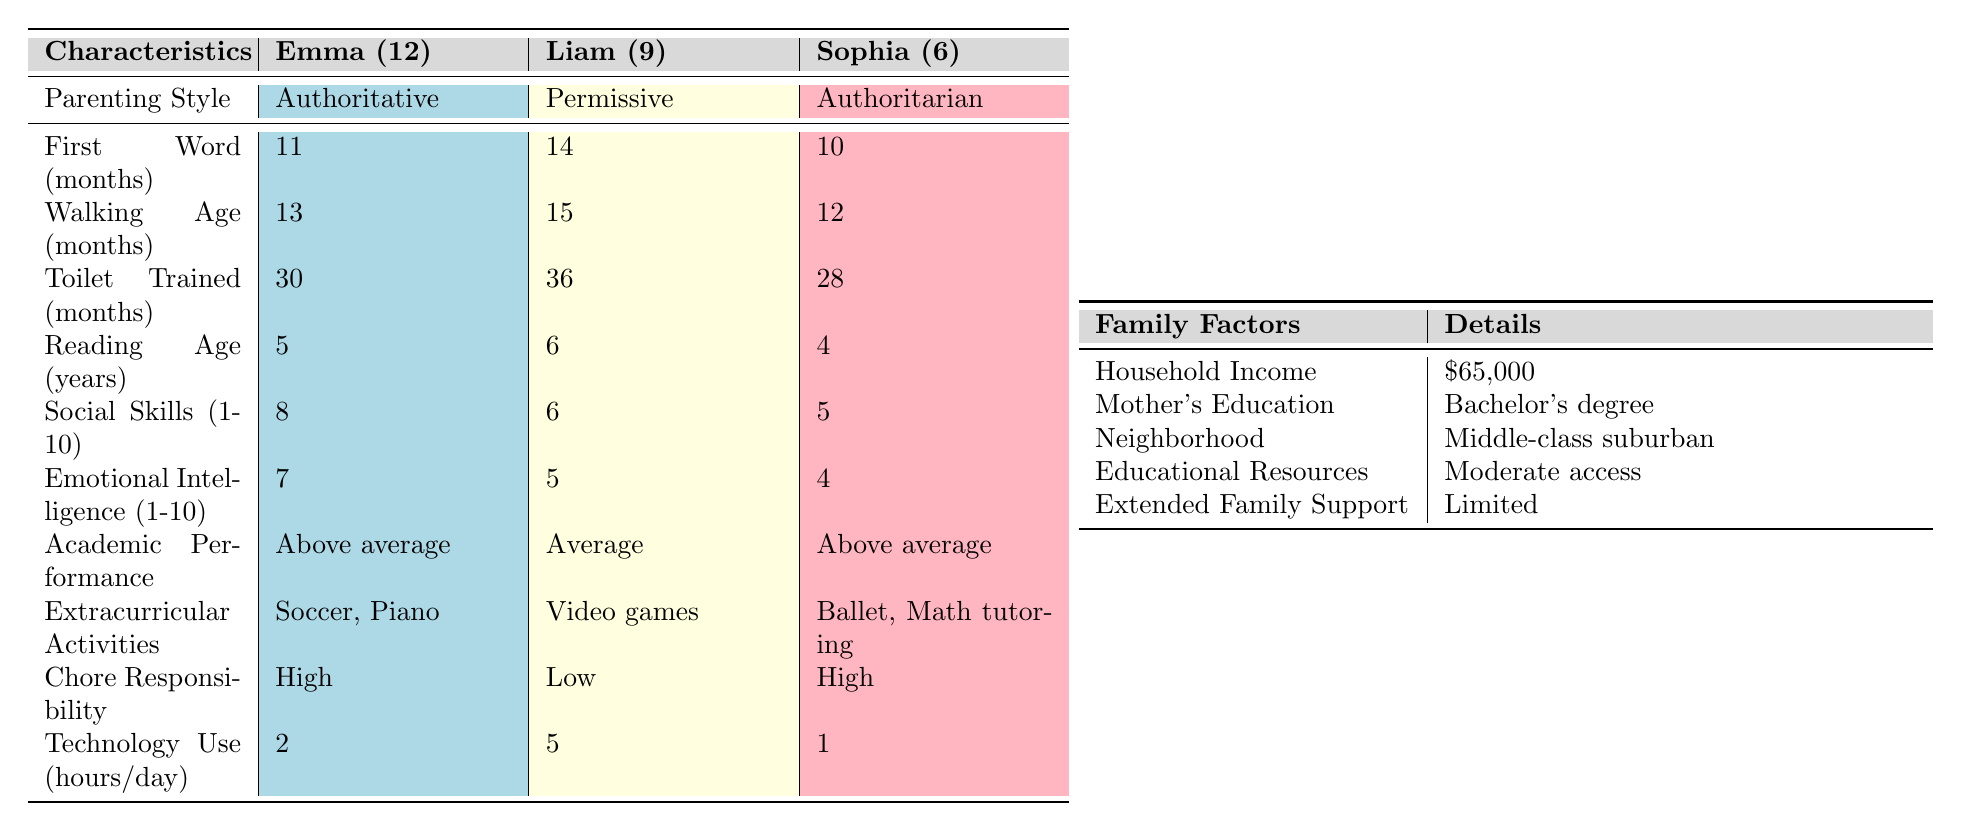What is Emma's reading age? The table indicates that Emma, who is 12 years old, has a reading age of 5 years.
Answer: 5 years At what age did Liam say his first word? According to the table, Liam said his first word at 14 months.
Answer: 14 months Which child has the highest social skills rating? Emma has a social skills rating of 8, which is higher than Liam's 6 and Sophia's 5.
Answer: Emma What is the difference in walking age between Emma and Sophia? Emma started walking at 13 months and Sophia at 12 months. The difference is 13 - 12 = 1 month.
Answer: 1 month Did Sophia achieve toilet training earlier than Liam? Sophia was toilet trained at 28 months, while Liam was toilet trained at 36 months. Therefore, yes, Sophia achieved it earlier.
Answer: Yes Which parenting style is associated with the highest emotional intelligence score? Emma, raised with an authoritative style, has the highest emotional intelligence score of 7 compared to Liam's 5 and Sophia's 4.
Answer: Authoritative What are the extracurricular activities of Liam? The table shows that Liam engages in video games as his extracurricular activity.
Answer: Video games How does the social skills rating compare between the children raised with authoritative and authoritarian parenting styles? Emma, raised with authoritative parenting, has a rating of 8, while Sophia, raised with authoritarian parenting, has a rating of 5. The comparison shows that Emma has a higher rating by 3 points.
Answer: Higher by 3 points What is the average technology use at home for the three children? The average technology use can be calculated as (2 + 5 + 1) / 3 = 8 / 3 ≈ 2.67 hours per day.
Answer: Approximately 2.67 hours per day Based on the data, does any child participate in more than one extracurricular activity? Emma participates in two activities (Soccer and Piano), while Liam and Sophia participate in only one. Therefore, yes, Emma is the only child who participates in multiple activities.
Answer: Yes 